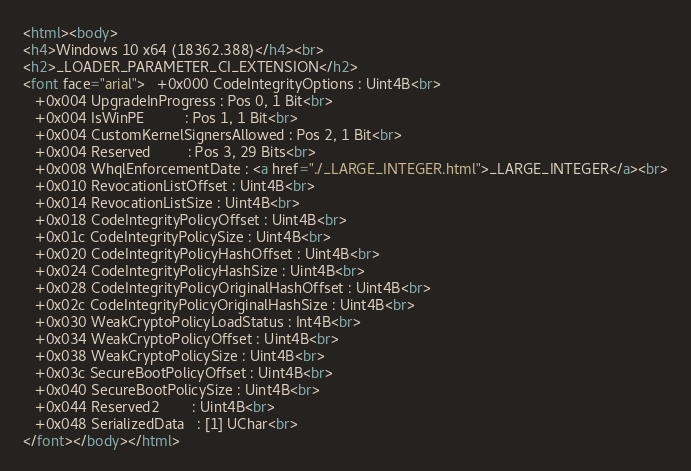Convert code to text. <code><loc_0><loc_0><loc_500><loc_500><_HTML_><html><body>
<h4>Windows 10 x64 (18362.388)</h4><br>
<h2>_LOADER_PARAMETER_CI_EXTENSION</h2>
<font face="arial">   +0x000 CodeIntegrityOptions : Uint4B<br>
   +0x004 UpgradeInProgress : Pos 0, 1 Bit<br>
   +0x004 IsWinPE          : Pos 1, 1 Bit<br>
   +0x004 CustomKernelSignersAllowed : Pos 2, 1 Bit<br>
   +0x004 Reserved         : Pos 3, 29 Bits<br>
   +0x008 WhqlEnforcementDate : <a href="./_LARGE_INTEGER.html">_LARGE_INTEGER</a><br>
   +0x010 RevocationListOffset : Uint4B<br>
   +0x014 RevocationListSize : Uint4B<br>
   +0x018 CodeIntegrityPolicyOffset : Uint4B<br>
   +0x01c CodeIntegrityPolicySize : Uint4B<br>
   +0x020 CodeIntegrityPolicyHashOffset : Uint4B<br>
   +0x024 CodeIntegrityPolicyHashSize : Uint4B<br>
   +0x028 CodeIntegrityPolicyOriginalHashOffset : Uint4B<br>
   +0x02c CodeIntegrityPolicyOriginalHashSize : Uint4B<br>
   +0x030 WeakCryptoPolicyLoadStatus : Int4B<br>
   +0x034 WeakCryptoPolicyOffset : Uint4B<br>
   +0x038 WeakCryptoPolicySize : Uint4B<br>
   +0x03c SecureBootPolicyOffset : Uint4B<br>
   +0x040 SecureBootPolicySize : Uint4B<br>
   +0x044 Reserved2        : Uint4B<br>
   +0x048 SerializedData   : [1] UChar<br>
</font></body></html></code> 